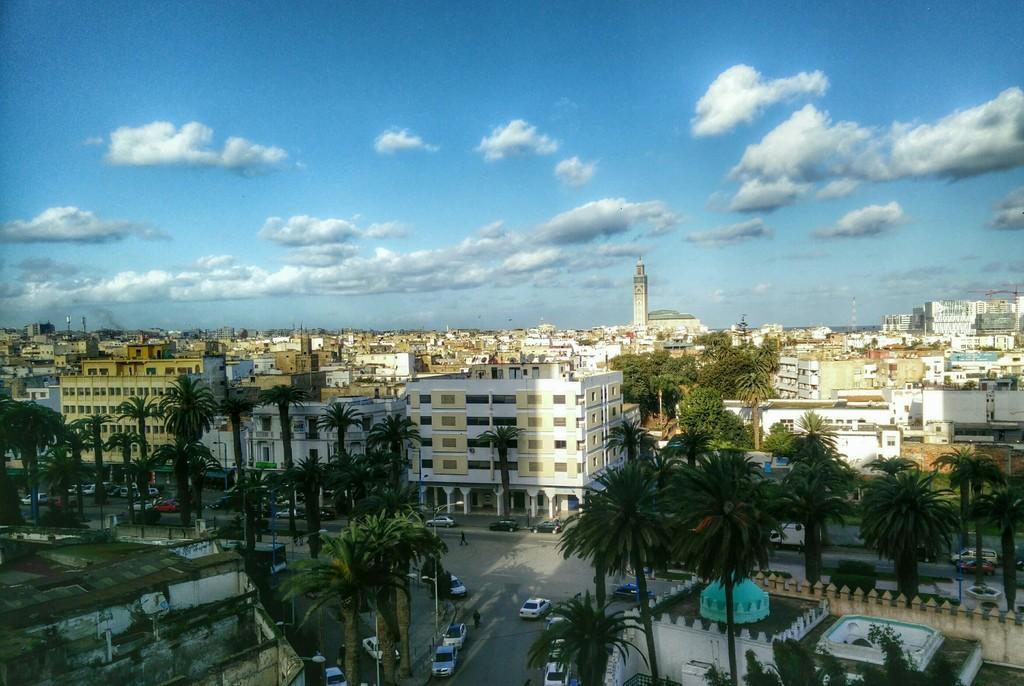Could you give a brief overview of what you see in this image? There are cars, trees and buildings are present at the bottom of this image and the cloudy sky is at the top of this image. 